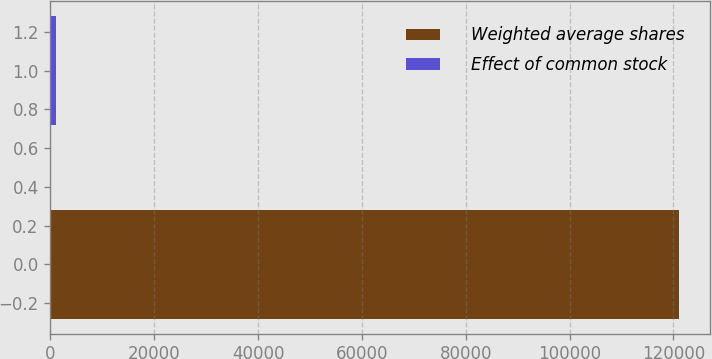<chart> <loc_0><loc_0><loc_500><loc_500><bar_chart><fcel>Weighted average shares<fcel>Effect of common stock<nl><fcel>120986<fcel>1062<nl></chart> 